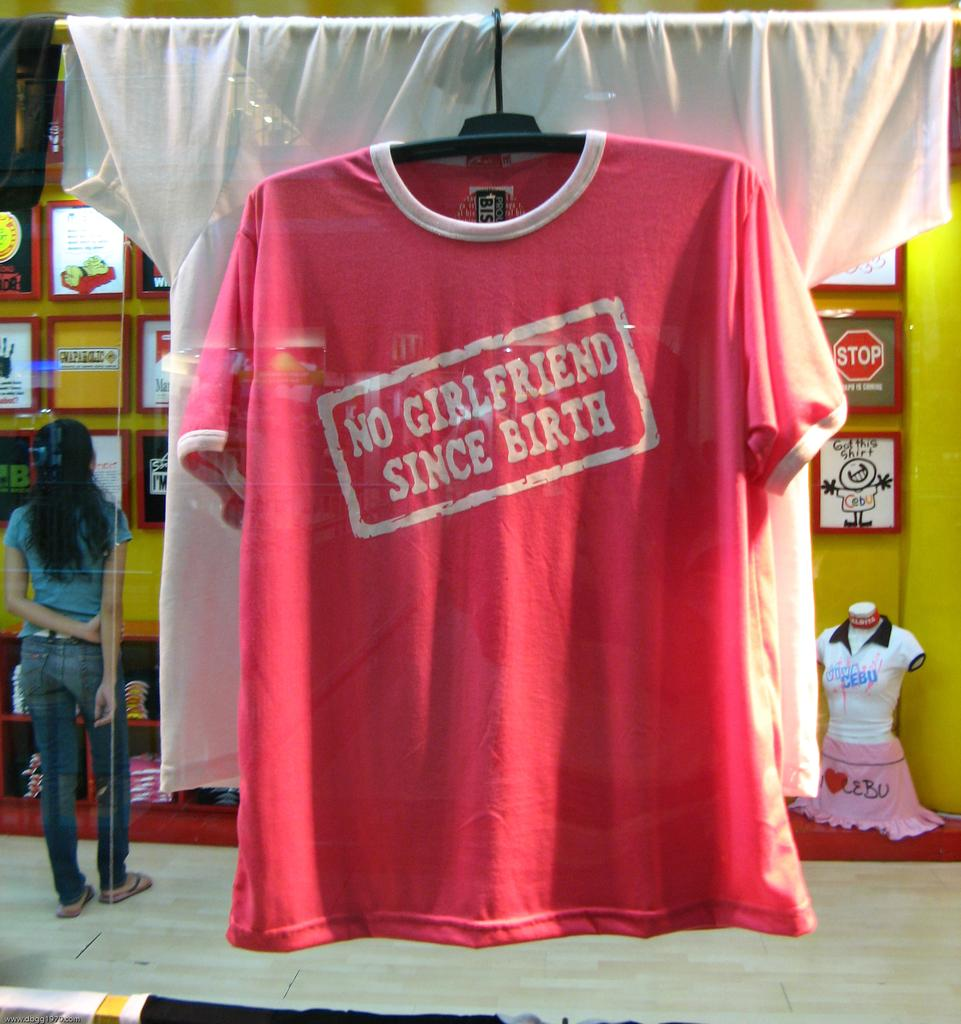<image>
Create a compact narrative representing the image presented. No Girlfriend Since Birth is printed onto the front of this t shirt. 